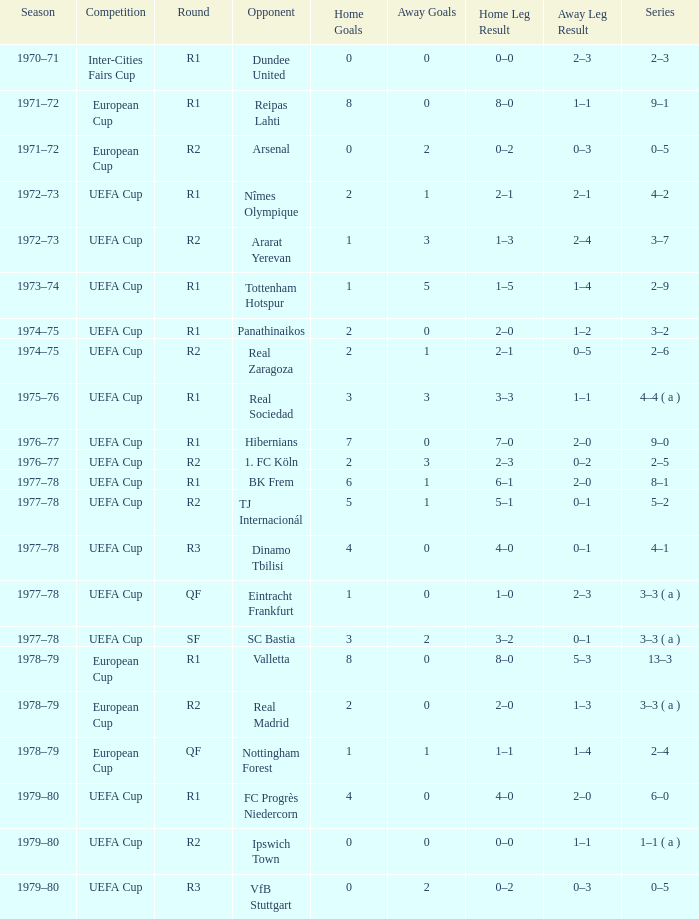Which Round has a Competition of uefa cup, and a Series of 5–2? R2. 